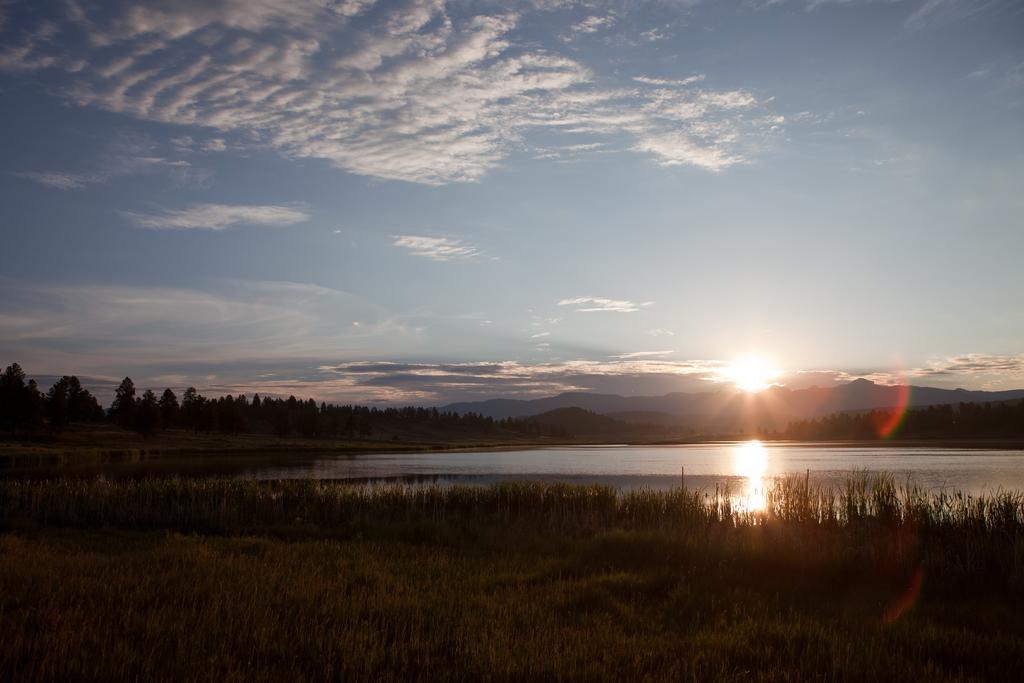Can you describe this image briefly? This image is clicked at a riverside. At the bottom there is a ground. There are plants and grass on the ground. There is water. In the background there are mountains and trees. At the top there is the sky. There is sun in the image. 